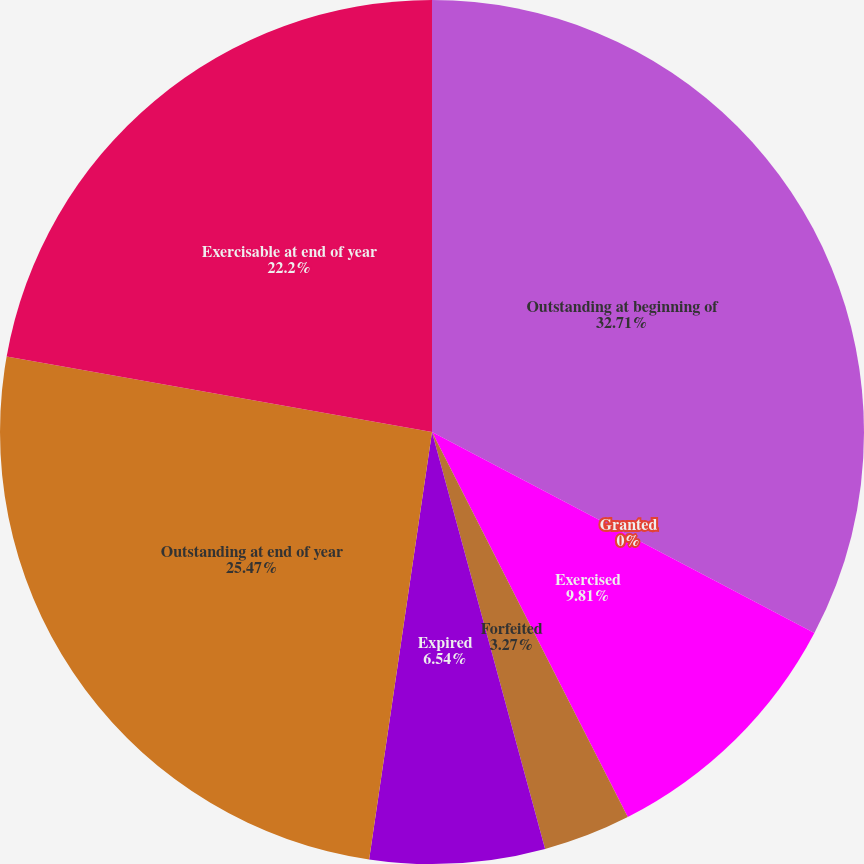<chart> <loc_0><loc_0><loc_500><loc_500><pie_chart><fcel>Outstanding at beginning of<fcel>Granted<fcel>Exercised<fcel>Forfeited<fcel>Expired<fcel>Outstanding at end of year<fcel>Exercisable at end of year<nl><fcel>32.7%<fcel>0.0%<fcel>9.81%<fcel>3.27%<fcel>6.54%<fcel>25.47%<fcel>22.2%<nl></chart> 